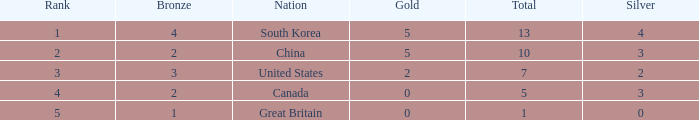What is the total number of Gold, when Silver is 2, and when Total is less than 7? 0.0. 